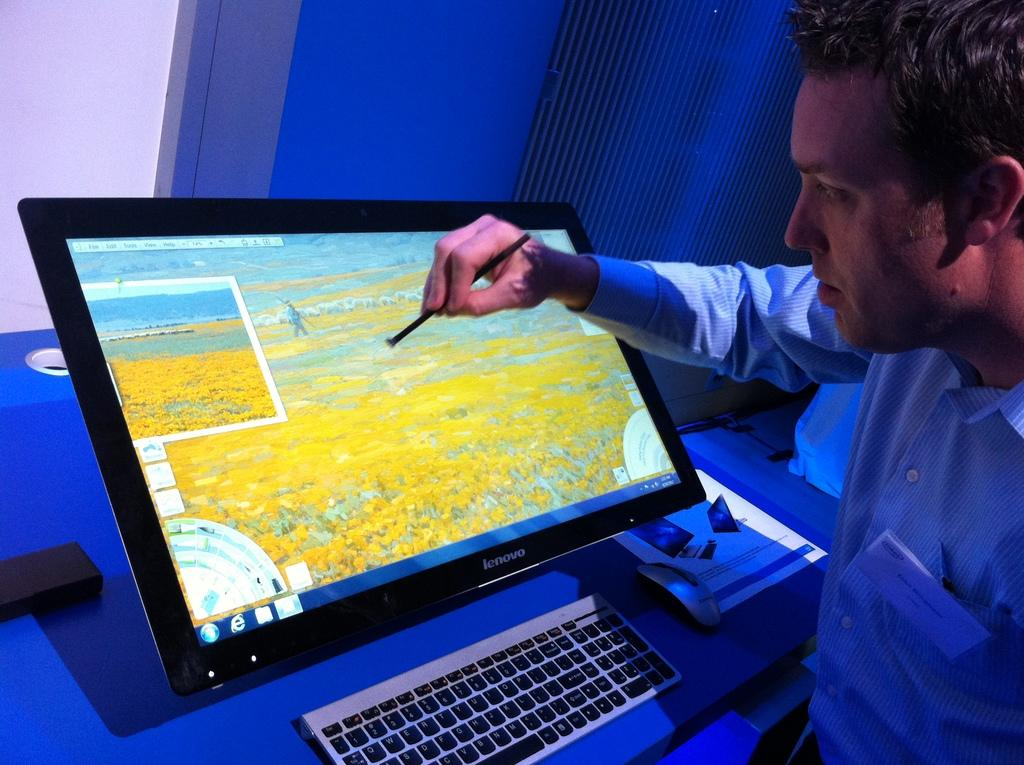<image>
Render a clear and concise summary of the photo. A wide screen monitor is made by the Lenovo corporation. 